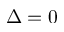Convert formula to latex. <formula><loc_0><loc_0><loc_500><loc_500>\Delta = 0</formula> 